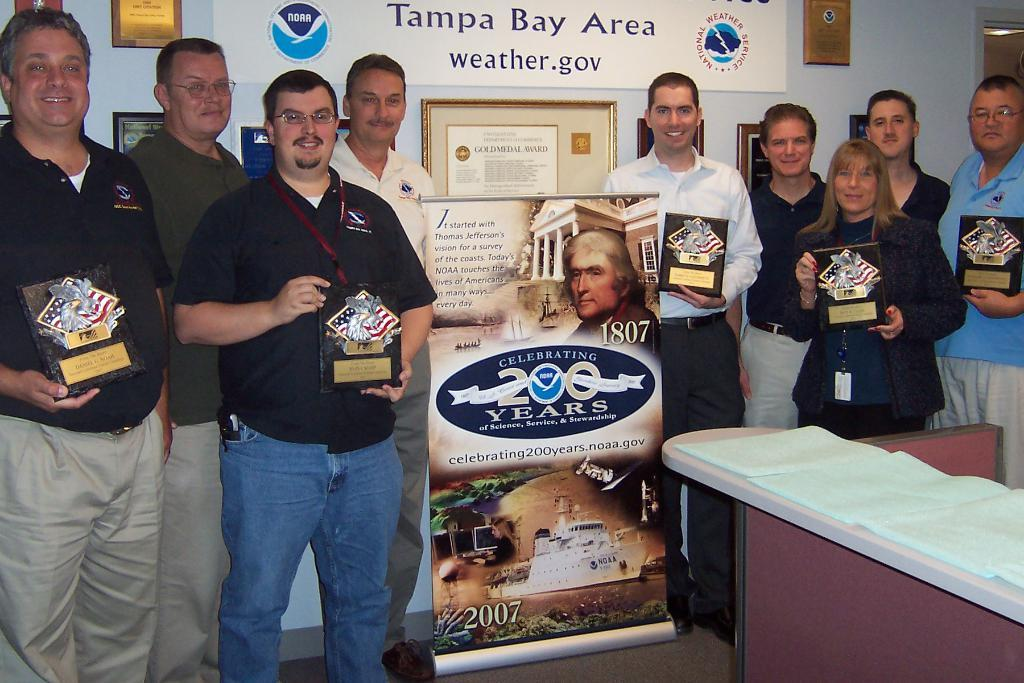<image>
Render a clear and concise summary of the photo. Several people stand in front of a board that says Tampa Bay Area weather.gov holding plaques 